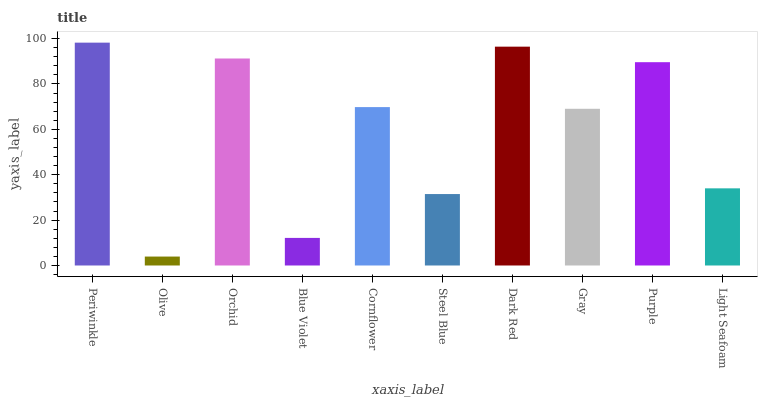Is Olive the minimum?
Answer yes or no. Yes. Is Periwinkle the maximum?
Answer yes or no. Yes. Is Orchid the minimum?
Answer yes or no. No. Is Orchid the maximum?
Answer yes or no. No. Is Orchid greater than Olive?
Answer yes or no. Yes. Is Olive less than Orchid?
Answer yes or no. Yes. Is Olive greater than Orchid?
Answer yes or no. No. Is Orchid less than Olive?
Answer yes or no. No. Is Cornflower the high median?
Answer yes or no. Yes. Is Gray the low median?
Answer yes or no. Yes. Is Gray the high median?
Answer yes or no. No. Is Cornflower the low median?
Answer yes or no. No. 